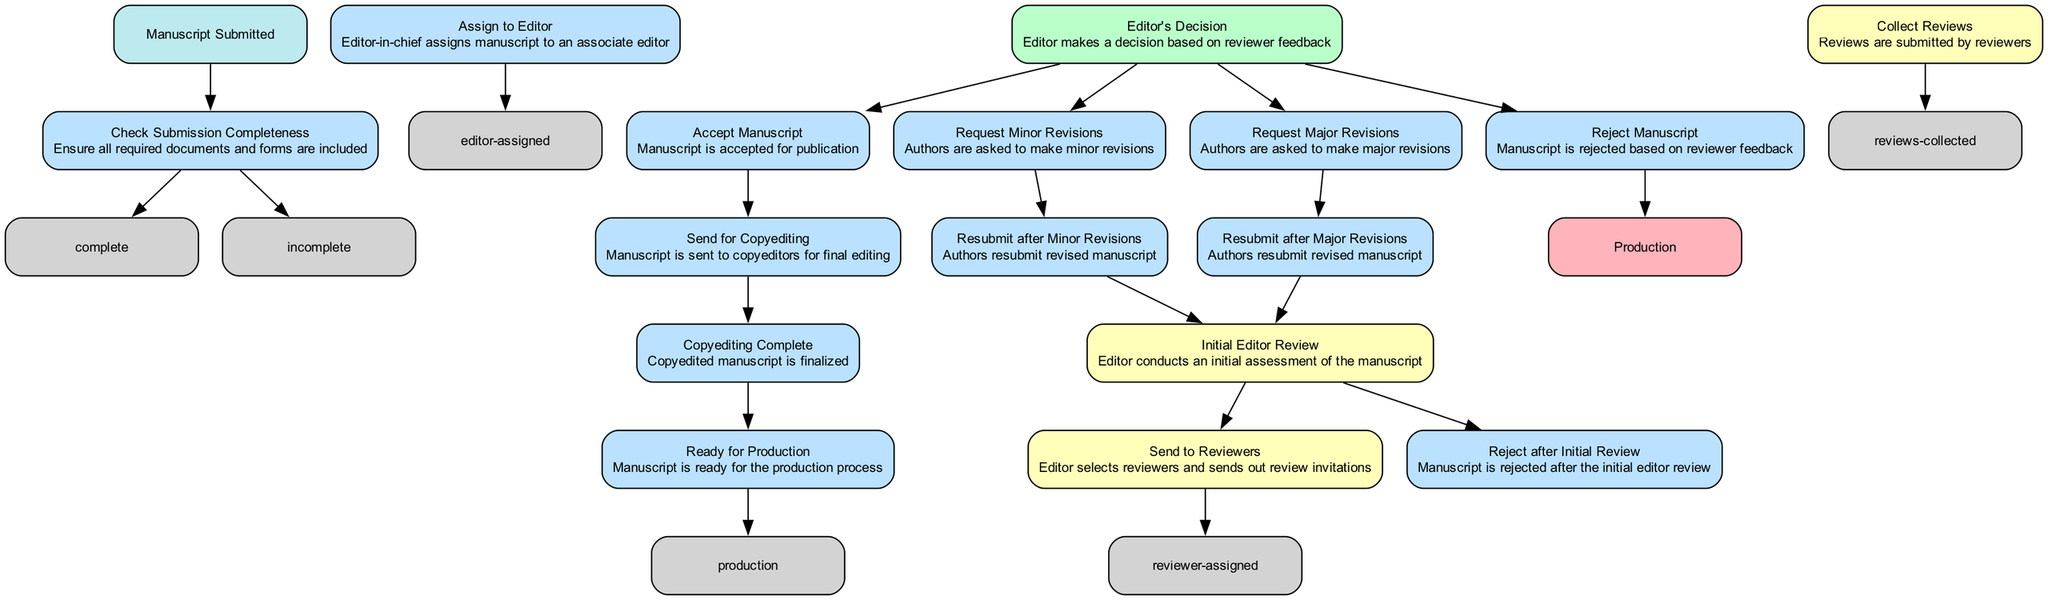What is the first step in the manuscript review process? The first step in the process, as indicated in the diagram, is "Manuscript Submitted." This is the starting point of the workflow.
Answer: Manuscript Submitted How many decision points are there in the workflow? By examining the diagram, we can identify four decision points, which involve the editor’s initial review and decision-making regarding the manuscript.
Answer: Four What action follows "Check Submission Completeness" if the submission is complete? If the submission is complete, the next action in the diagram is "Assign to Editor," which involves assigning the manuscript to an associate editor.
Answer: Assign to Editor What happens after a manuscript is accepted for publication? After a manuscript is accepted for publication, the next step in the diagram is "Send for Copyediting," which means that the accepted manuscript will undergo final editing.
Answer: Send for Copyediting How many total steps (process nodes) are there in the manuscript review workflow? The diagram shows a total of twelve process nodes (steps) that describe various actions taken during the manuscript review workflow.
Answer: Twelve Which step leads to "Collect Reviews"? The step that leads to "Collect Reviews" is "Send to Reviewers," as indicated by the flow in the diagram where invitations to reviewers are sent, allowing for the collection of their feedback.
Answer: Send to Reviewers What is the final outcome represented in the diagram? The final outcome of the workflow as represented in the diagram is "Production," which happens after the manuscript has successfully gone through all prior steps.
Answer: Production What type of revisions can the editor request? The editor can request either "Minor Revisions" or "Major Revisions," as outlined in the decision nodes of the workflow diagram.
Answer: Minor and Major Revisions What happens if the manuscript is rejected after the initial review? If the manuscript is rejected after the initial review, the process ends there, as indicated by the "Reject after Initial Review" step, which has no following actions.
Answer: Reject after Initial Review 